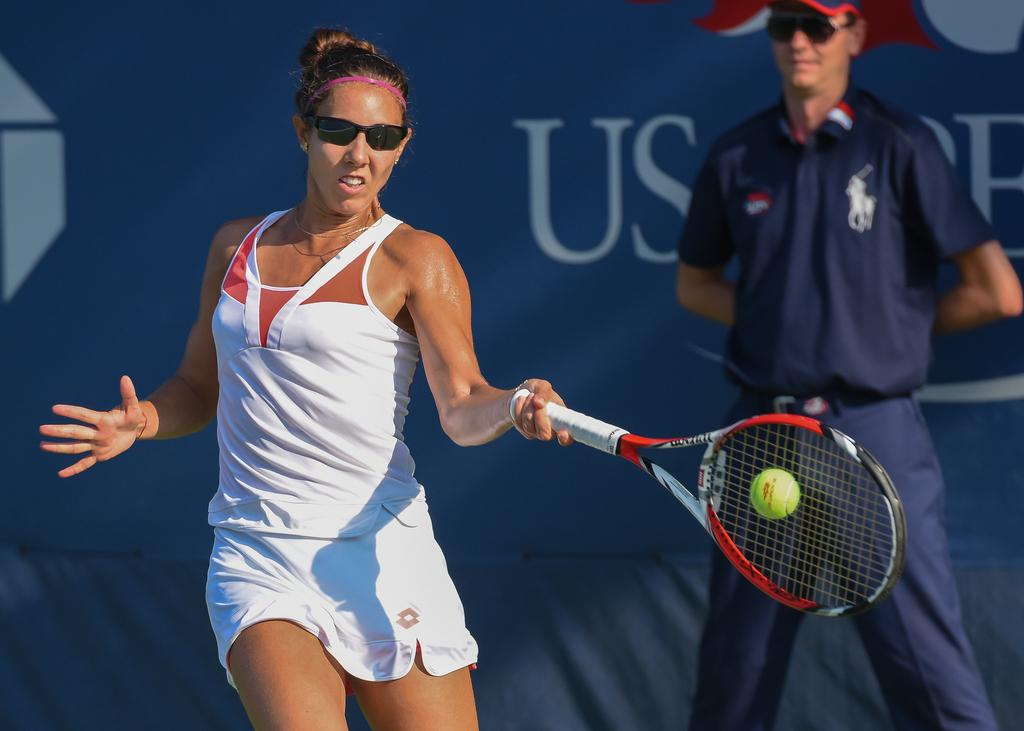What activity is the person in the image engaged in? There is a person playing tennis in the image. Can you describe the other person in the image? There is another person standing in the image. What can be seen at the back of the image? There is a banner at the back of the image. Can you tell me what type of sail is visible on the river in the image? There is no sail or river present in the image; it features a person playing tennis and another person standing, with a banner at the back. 